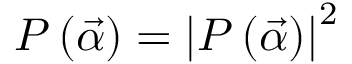Convert formula to latex. <formula><loc_0><loc_0><loc_500><loc_500>P \left ( \vec { \alpha } \right ) = \left | P \left ( \vec { \alpha } \right ) \right | ^ { 2 }</formula> 